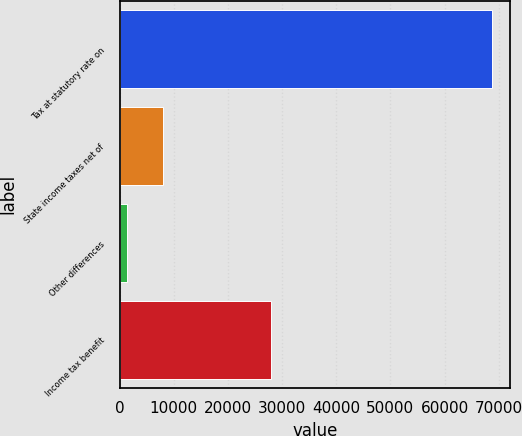Convert chart. <chart><loc_0><loc_0><loc_500><loc_500><bar_chart><fcel>Tax at statutory rate on<fcel>State income taxes net of<fcel>Other differences<fcel>Income tax benefit<nl><fcel>68720<fcel>8081.6<fcel>1344<fcel>28042<nl></chart> 